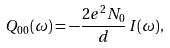Convert formula to latex. <formula><loc_0><loc_0><loc_500><loc_500>Q _ { 0 0 } ( \omega ) = - \frac { 2 e ^ { 2 } N _ { 0 } } { d } \, I ( \omega ) ,</formula> 